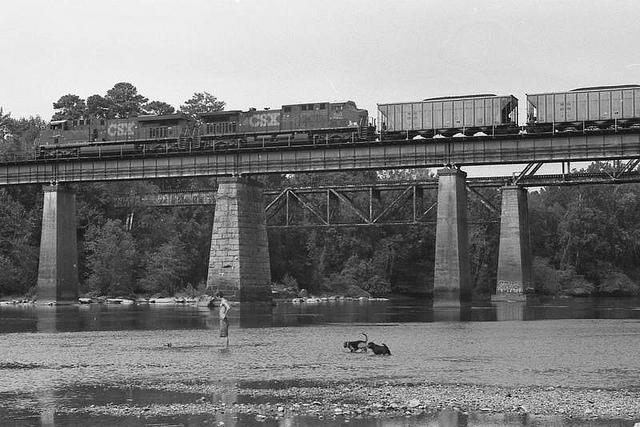Why is the train on a bridge? Please explain your reasoning. crossing river. Trains can't pass through water. 